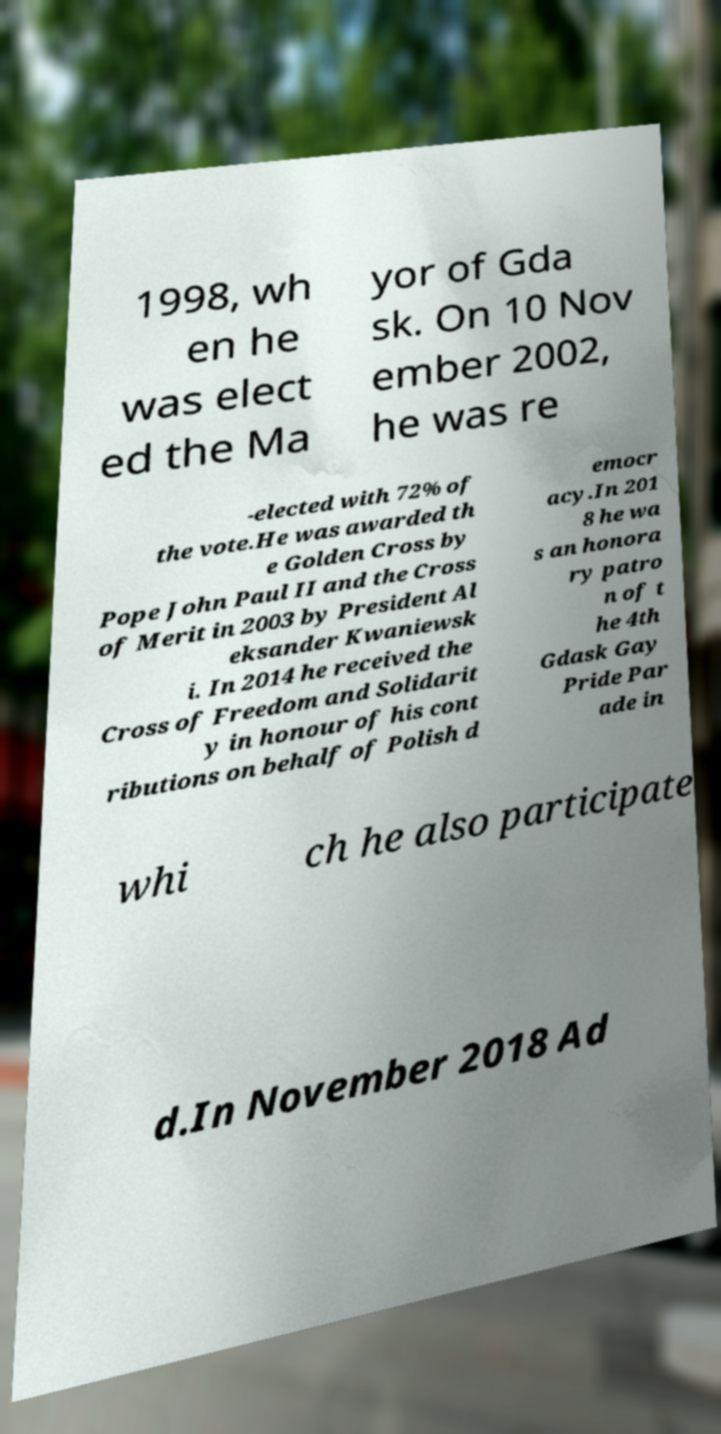Can you read and provide the text displayed in the image?This photo seems to have some interesting text. Can you extract and type it out for me? 1998, wh en he was elect ed the Ma yor of Gda sk. On 10 Nov ember 2002, he was re -elected with 72% of the vote.He was awarded th e Golden Cross by Pope John Paul II and the Cross of Merit in 2003 by President Al eksander Kwaniewsk i. In 2014 he received the Cross of Freedom and Solidarit y in honour of his cont ributions on behalf of Polish d emocr acy.In 201 8 he wa s an honora ry patro n of t he 4th Gdask Gay Pride Par ade in whi ch he also participate d.In November 2018 Ad 